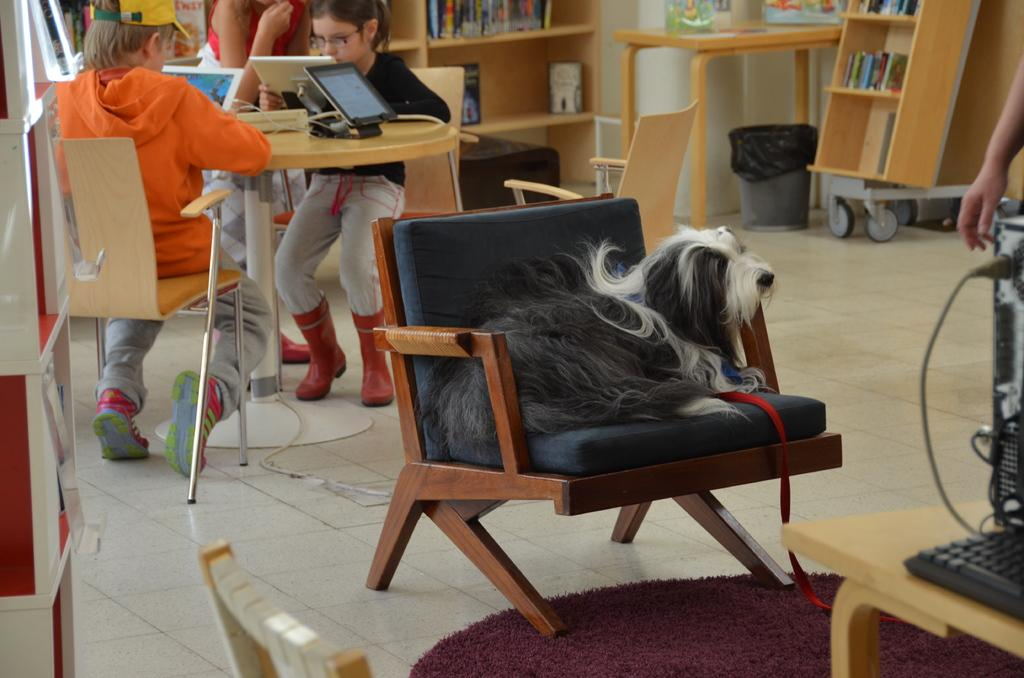How many people are in the image? There are two people in the image, a boy and a girl. What are the boy and girl doing in the image? Both the boy and girl are seated on chairs and playing with tablets. What else can be seen in the image besides the people and tablets? There is a dog in the image, and it is seated on a chair. What type of furniture is present in the image? There are chairs and bookshelves in the image. What type of bean is being used to divide the books on the bookshelves in the image? There are no beans present in the image, and the books on the bookshelves are not being divided. How does the show being watched on the tablets affect the dog's behavior in the image? There is no indication in the image that the dog is watching a show on the tablets, and therefore its behavior is not affected by any show. 